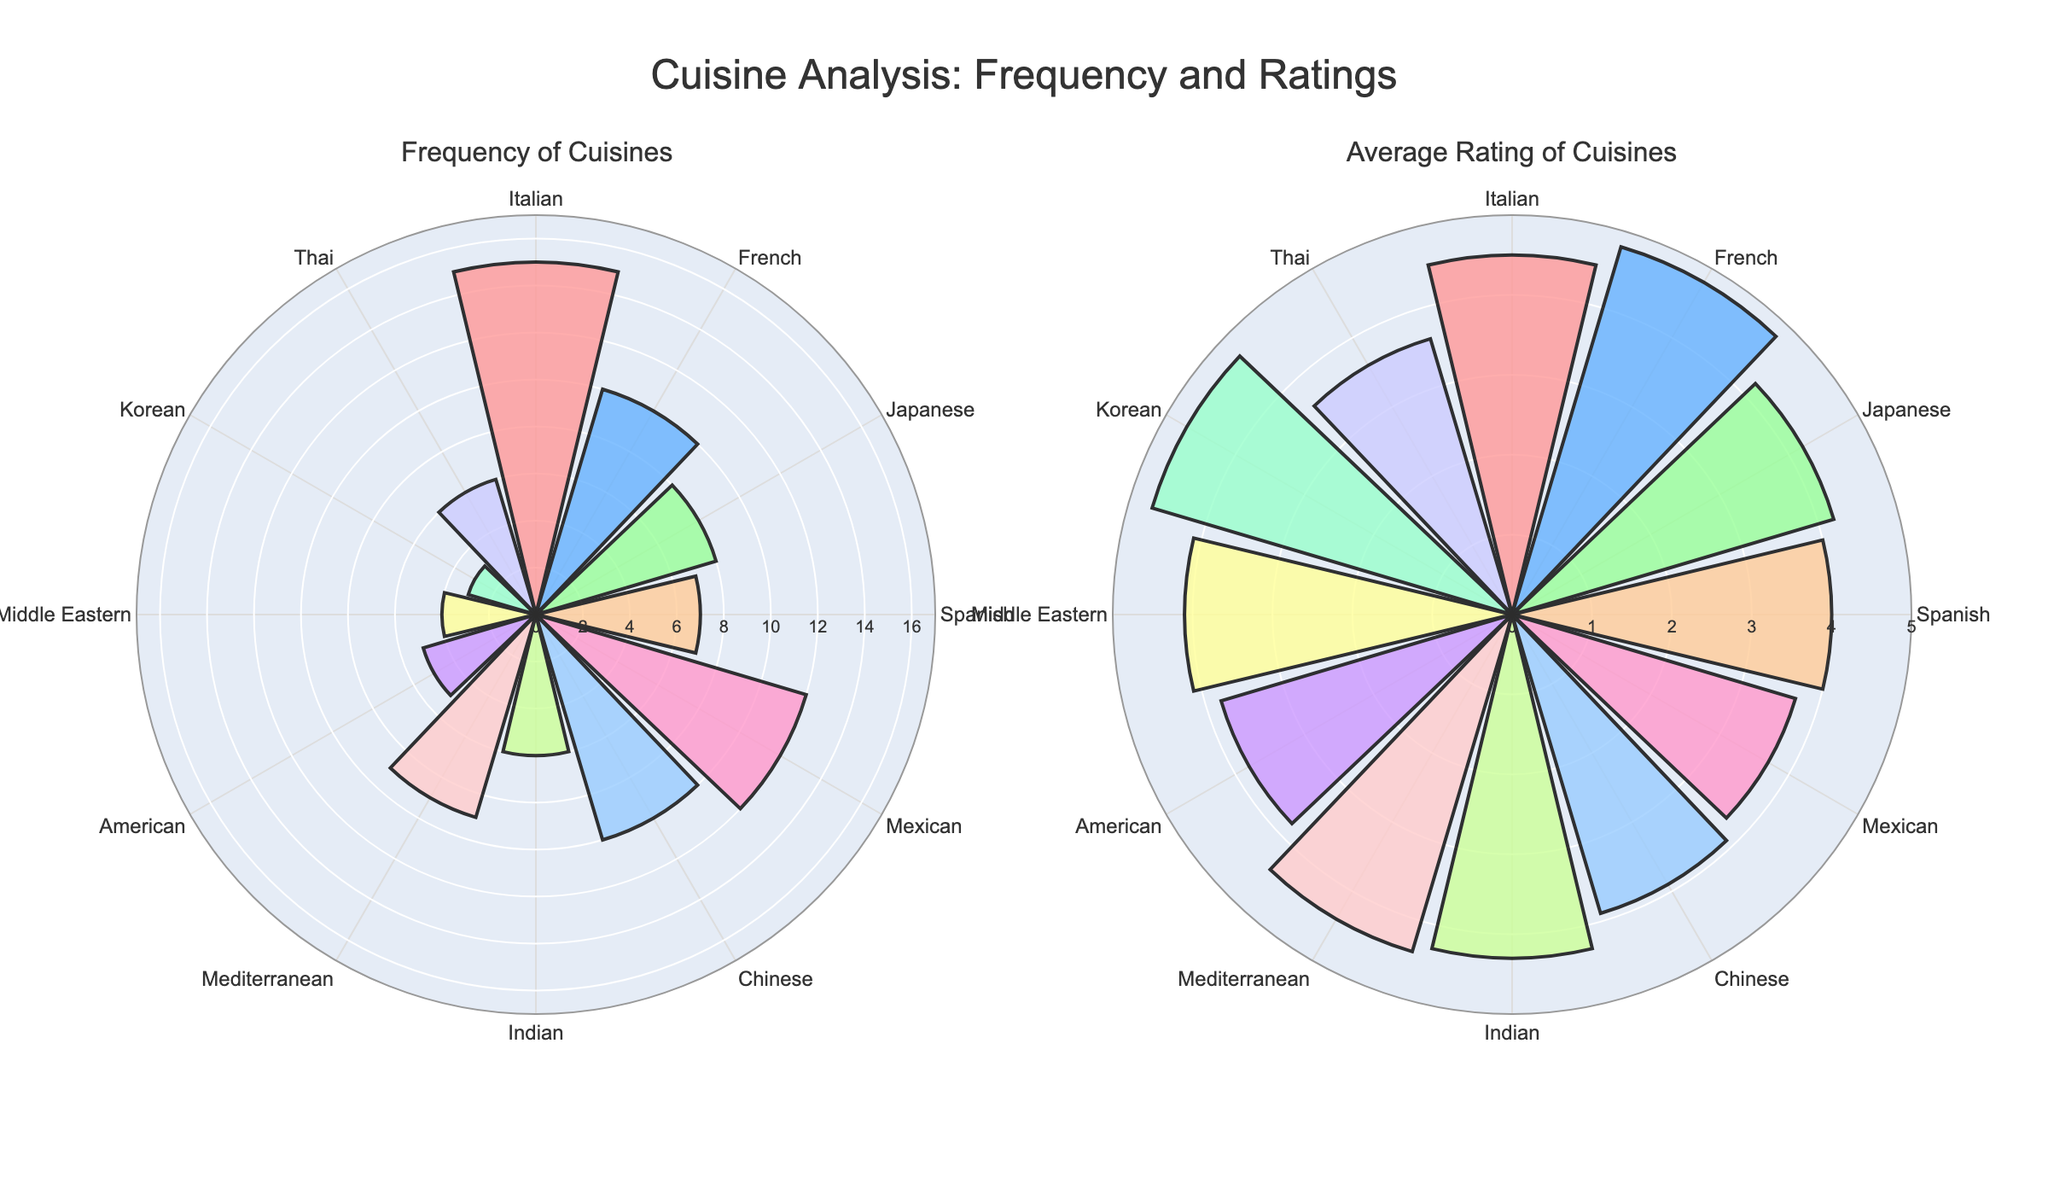Which cuisine has the highest frequency of reviews? To answer this, locate the subplot titled "Frequency of Cuisines" and find the cuisine that has the longest bar.
Answer: Italian Which cuisine has the highest average rating? Check the "Average Rating of Cuisines" subplot and identify the cuisine with the tallest bar.
Answer: French Which cuisine has both a high frequency of reviews and a high average rating? Observe both subplots. Identify a cuisine that is prominent in both "Frequency of Cuisines" and "Average Rating of Cuisines."
Answer: Italian What is the average rating of Japanese cuisine? Look at the "Average Rating of Cuisines" subplot and find the bar labeled Japanese to read its height.
Answer: 4.2 Compare the frequency and average rating of Mexican cuisine. How do these two metrics relate? In the "Frequency of Cuisines," find Mexican and note the bar's height. Then, do the same in the "Average Rating of Cuisines." Compare both values quantitatively.
Answer: Frequency: 12, Average Rating: 3.7 Which cuisines have a higher average rating than the Mexican cuisine? In the "Average Rating of Cuisines" subplot, locate Mexican cuisine’s bar. Identify all bars taller than this.
Answer: Italian, French, Japanese, Indian, Mediterranean, Middle Eastern, Korean Which cuisines have a lower frequency of reviews than Mediterranean cuisine? In the "Frequency of Cuisines" subplot, find Mediterranean cuisine’s bar. Identify all bars shorter than this.
Answer: American, Middle Eastern, Korean, Thai, Indian What is the total frequency of cuisines with an average rating above 4.0? Identify cuisines with ratings above 4.0 in the "Average Rating of Cuisines" subplot, then sum their frequencies from the "Frequency of Cuisines" subplot. Cuisines: Italian, French, Japanese, Indian, Mediterranean, Middle Eastern, Korean. Total Frequency: 15+10+8+6+9+4+3 = 55.
Answer: 55 Compare the average ratings of Asian cuisines (Japanese, Chinese, Indian, Korean, and Thai). Which one has the highest and the lowest rating? Identify the bars in the "Average Rating of Cuisines" subplot for Japanese, Chinese, Indian, Korean, and Thai cuisines, and compare their heights.
Answer: Highest: Korean (4.7), Lowest: Thai (3.6) What is the difference in average rating between the highest-rated and lowest-rated cuisines? Identify the highest bar in "Average Rating of Cuisines" subplot (French, 4.8) and the lowest bar (Mexican, 3.7). Calculate their difference.
Answer: 1.1 